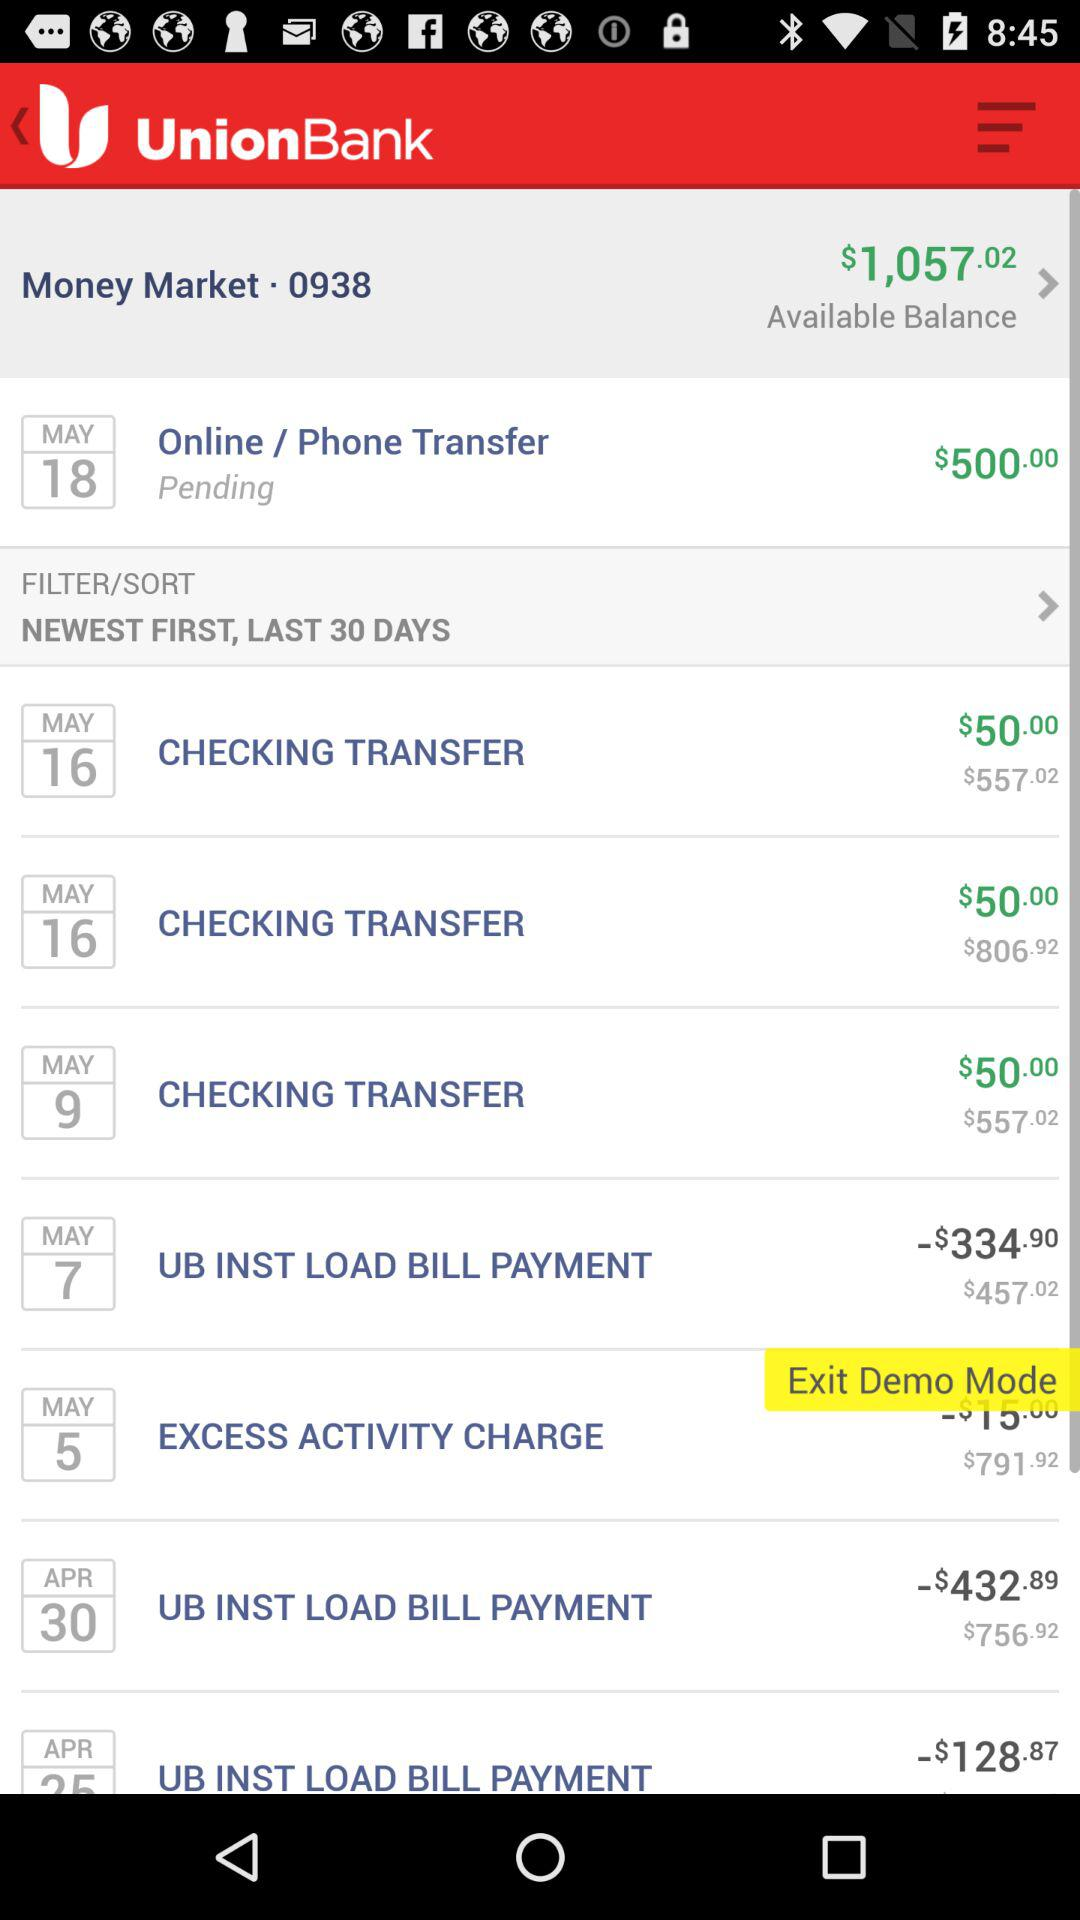How much is the total amount of money I have?
Answer the question using a single word or phrase. $1,057.02 